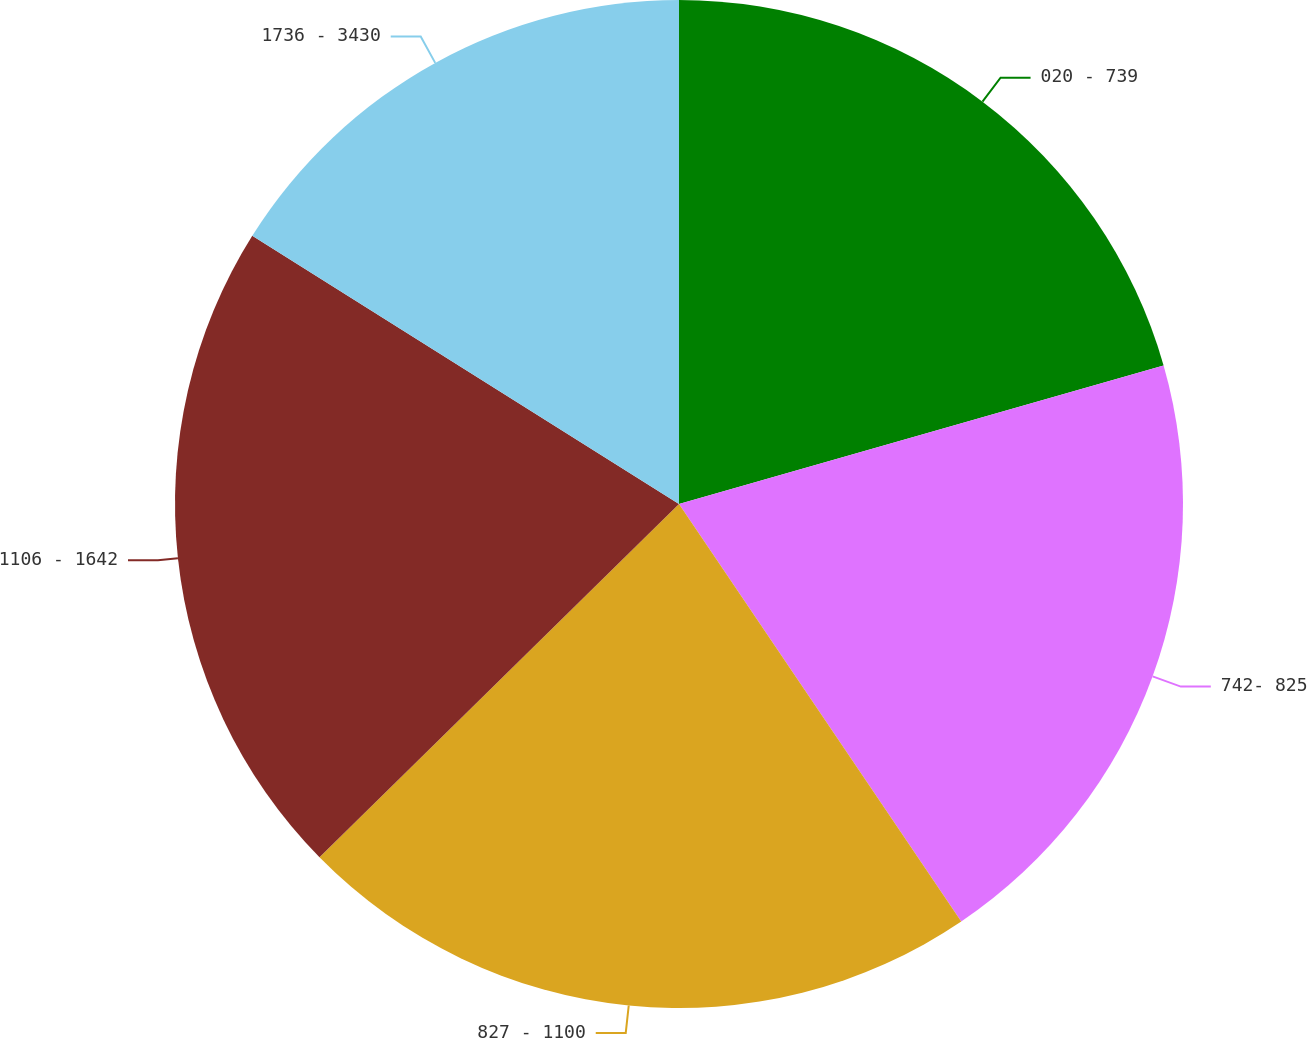Convert chart. <chart><loc_0><loc_0><loc_500><loc_500><pie_chart><fcel>020 - 739<fcel>742- 825<fcel>827 - 1100<fcel>1106 - 1642<fcel>1736 - 3430<nl><fcel>20.57%<fcel>19.97%<fcel>22.1%<fcel>21.29%<fcel>16.07%<nl></chart> 